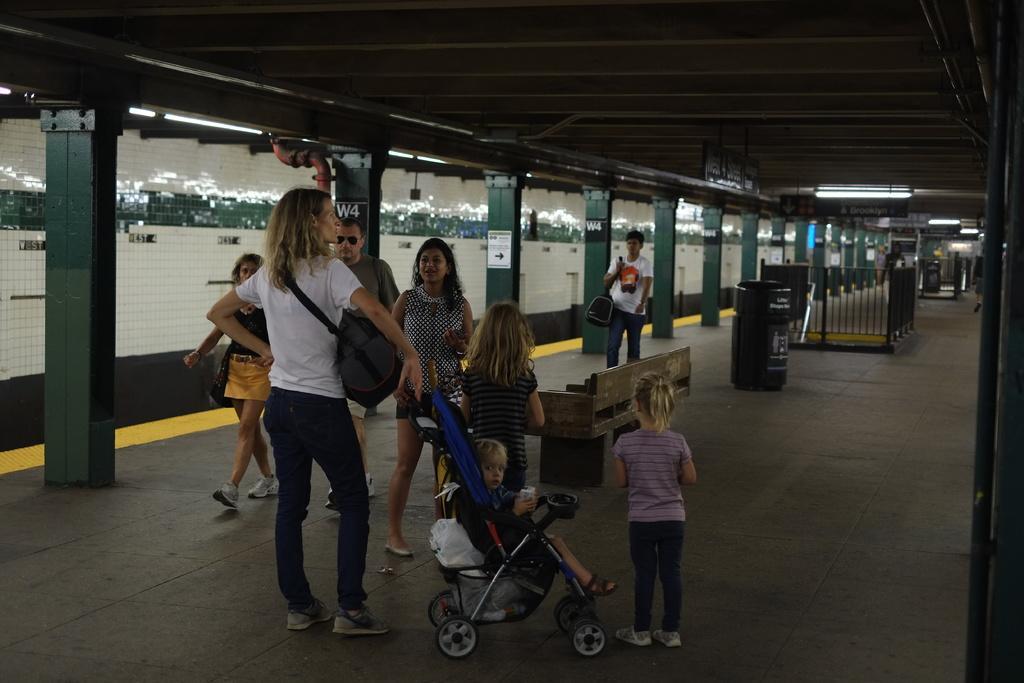In one or two sentences, can you explain what this image depicts? In this picture I can see group of people standing, there is a kid in a stroller, there are boards, lights, dustbins, iron grilles, bench and there are pillars. 